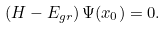<formula> <loc_0><loc_0><loc_500><loc_500>\left ( H - E _ { g r } \right ) \Psi ( x _ { 0 } ) = 0 .</formula> 